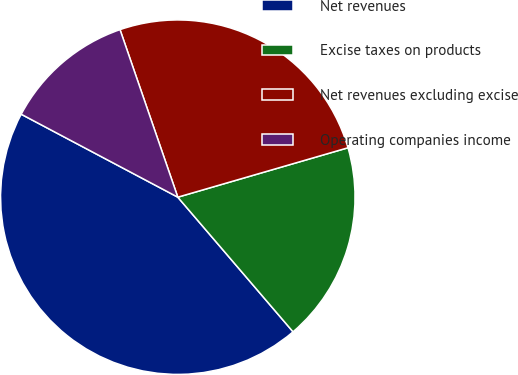Convert chart. <chart><loc_0><loc_0><loc_500><loc_500><pie_chart><fcel>Net revenues<fcel>Excise taxes on products<fcel>Net revenues excluding excise<fcel>Operating companies income<nl><fcel>44.02%<fcel>18.23%<fcel>25.79%<fcel>11.96%<nl></chart> 